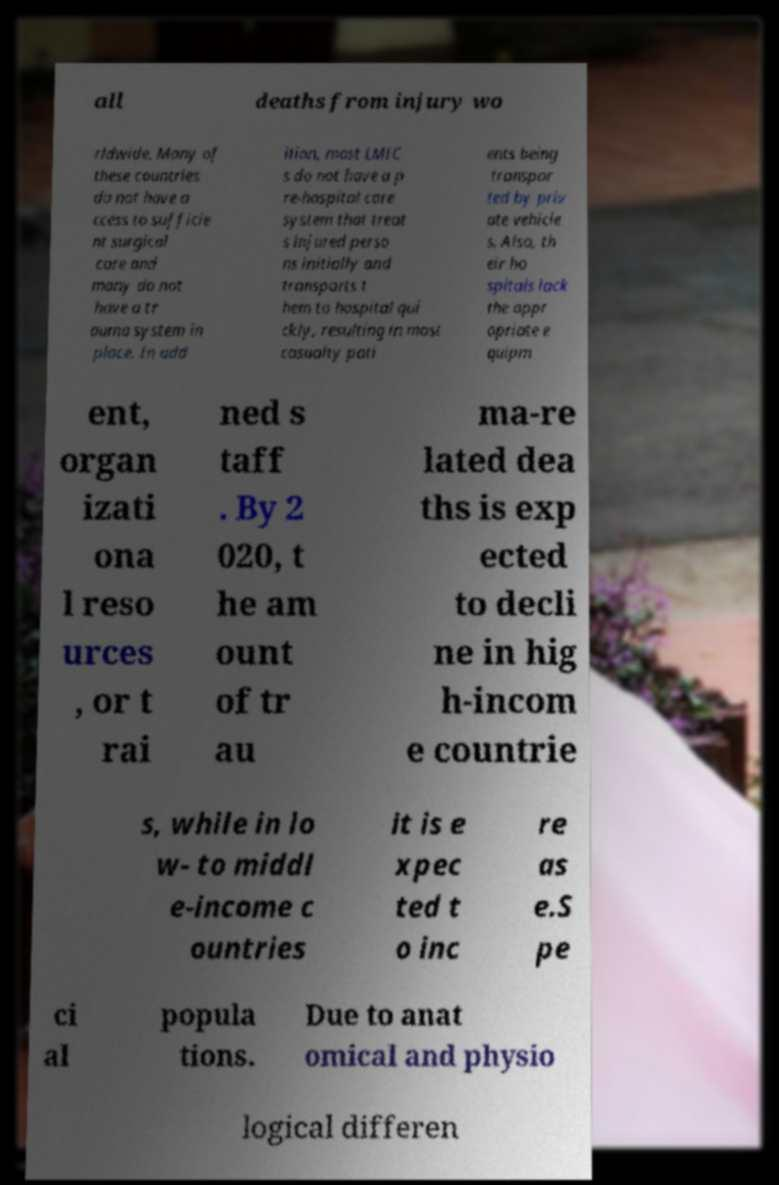I need the written content from this picture converted into text. Can you do that? all deaths from injury wo rldwide. Many of these countries do not have a ccess to sufficie nt surgical care and many do not have a tr auma system in place. In add ition, most LMIC s do not have a p re-hospital care system that treat s injured perso ns initially and transports t hem to hospital qui ckly, resulting in most casualty pati ents being transpor ted by priv ate vehicle s. Also, th eir ho spitals lack the appr opriate e quipm ent, organ izati ona l reso urces , or t rai ned s taff . By 2 020, t he am ount of tr au ma-re lated dea ths is exp ected to decli ne in hig h-incom e countrie s, while in lo w- to middl e-income c ountries it is e xpec ted t o inc re as e.S pe ci al popula tions. Due to anat omical and physio logical differen 